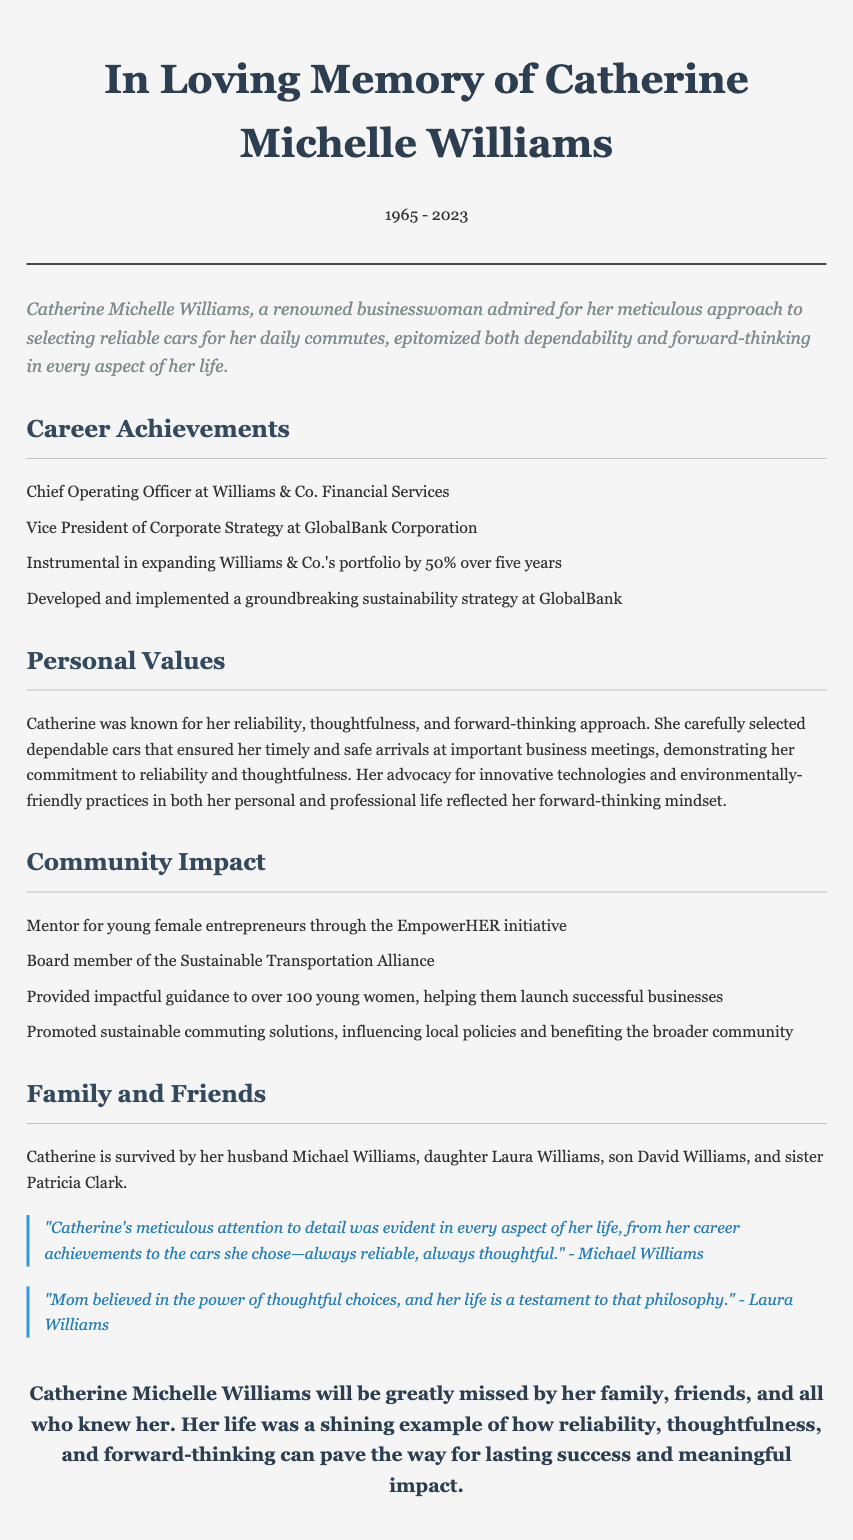what was Catherine's role at Williams & Co.? Catherine was the Chief Operating Officer at Williams & Co. Financial Services.
Answer: Chief Operating Officer how many years did it take for Williams & Co.'s portfolio to expand by 50%? The portfolio expansion was achieved over a period of five years.
Answer: five years which initiative did Catherine mentor young female entrepreneurs through? Catherine mentored young female entrepreneurs through the EmpowerHER initiative.
Answer: EmpowerHER initiative who is quoted as saying Catherine's attention to detail was evident in her life? The quote regarding Catherine's attention to detail is attributed to her husband, Michael Williams.
Answer: Michael Williams what was one of Catherine's key personal values? Catherine was known for her reliability.
Answer: reliability how many young women did Catherine provide guidance to? Catherine provided impactful guidance to over 100 young women.
Answer: over 100 who survived Catherine? Catherine is survived by her husband Michael Williams, daughter Laura Williams, son David Williams, and sister Patricia Clark.
Answer: Michael, Laura, David, Patricia what is the significance of the cars Catherine selected? The cars Catherine selected reflected her commitment to reliability and thoughtfulness.
Answer: reliability and thoughtfulness what was the final thought shared about Catherine's life? Catherine's life was a shining example of how reliability, thoughtfulness, and forward-thinking can pave the way for lasting success and meaningful impact.
Answer: reliability, thoughtfulness, and forward-thinking 